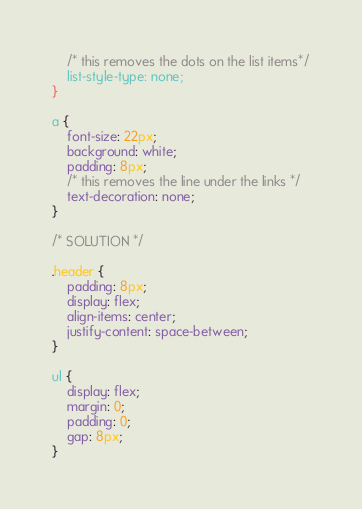Convert code to text. <code><loc_0><loc_0><loc_500><loc_500><_CSS_>	/* this removes the dots on the list items*/
	list-style-type: none;
}

a {
	font-size: 22px;
	background: white;
	padding: 8px;
	/* this removes the line under the links */
	text-decoration: none;
}

/* SOLUTION */

.header {
	padding: 8px;
	display: flex;
	align-items: center;
	justify-content: space-between;
}

ul {
	display: flex;
	margin: 0;
	padding: 0;
	gap: 8px;
}
</code> 